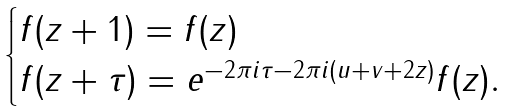<formula> <loc_0><loc_0><loc_500><loc_500>\begin{cases} f ( z + 1 ) = f ( z ) & \\ f ( z + \tau ) = e ^ { - 2 \pi i \tau - 2 \pi i ( u + v + 2 z ) } f ( z ) . & \end{cases}</formula> 